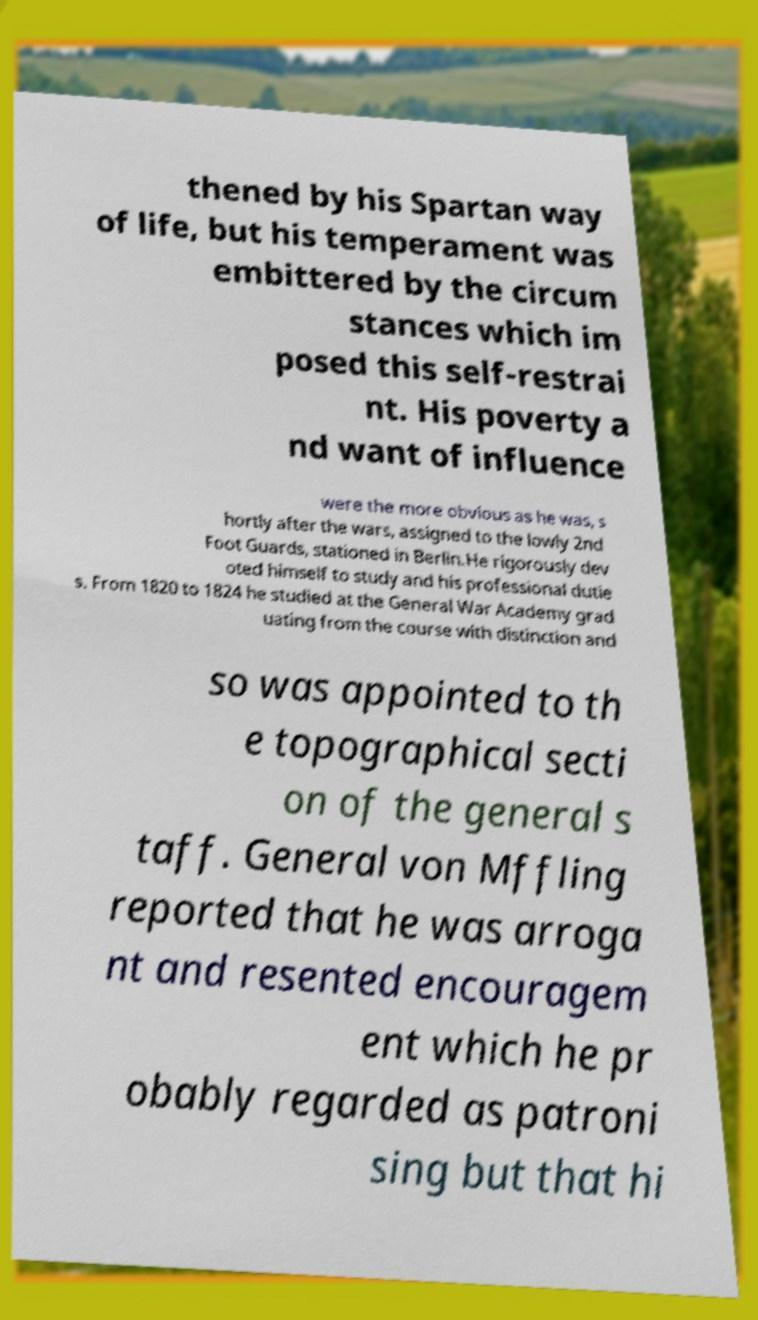Could you assist in decoding the text presented in this image and type it out clearly? thened by his Spartan way of life, but his temperament was embittered by the circum stances which im posed this self-restrai nt. His poverty a nd want of influence were the more obvious as he was, s hortly after the wars, assigned to the lowly 2nd Foot Guards, stationed in Berlin.He rigorously dev oted himself to study and his professional dutie s. From 1820 to 1824 he studied at the General War Academy grad uating from the course with distinction and so was appointed to th e topographical secti on of the general s taff. General von Mffling reported that he was arroga nt and resented encouragem ent which he pr obably regarded as patroni sing but that hi 